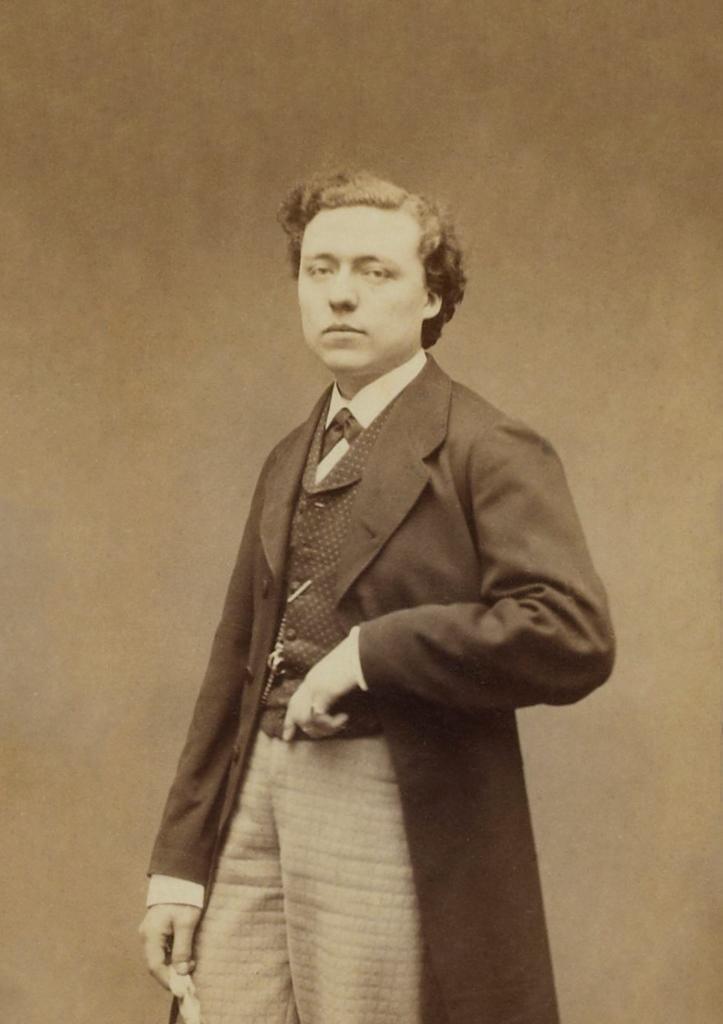Can you describe this image briefly? In this picture we can see a person standing in the front, this person wore a suit, it is a black and white picture. 